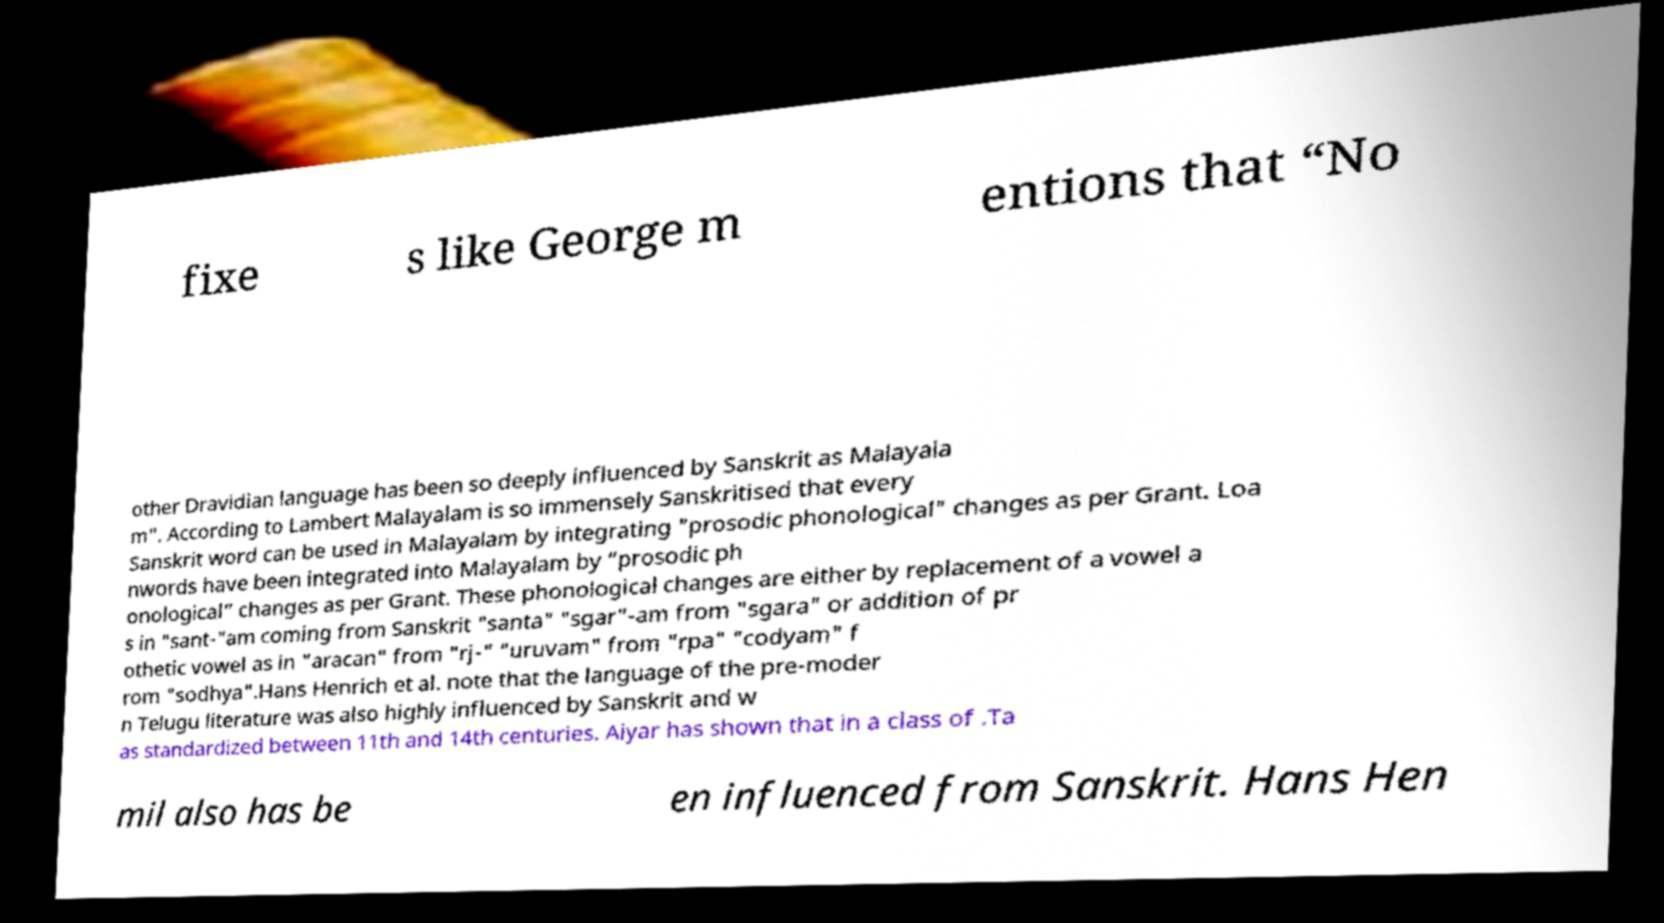Could you extract and type out the text from this image? fixe s like George m entions that “No other Dravidian language has been so deeply influenced by Sanskrit as Malayala m". According to Lambert Malayalam is so immensely Sanskritised that every Sanskrit word can be used in Malayalam by integrating "prosodic phonological" changes as per Grant. Loa nwords have been integrated into Malayalam by “prosodic ph onological” changes as per Grant. These phonological changes are either by replacement of a vowel a s in "sant-"am coming from Sanskrit "santa" "sgar"-am from "sgara" or addition of pr othetic vowel as in "aracan" from "rj-" "uruvam" from "rpa" "codyam" f rom "sodhya".Hans Henrich et al. note that the language of the pre-moder n Telugu literature was also highly influenced by Sanskrit and w as standardized between 11th and 14th centuries. Aiyar has shown that in a class of .Ta mil also has be en influenced from Sanskrit. Hans Hen 